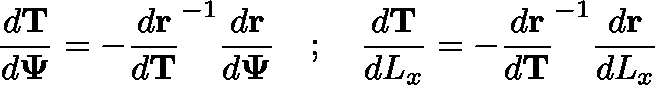Convert formula to latex. <formula><loc_0><loc_0><loc_500><loc_500>\frac { d T } { d \Psi } = - \frac { d r } { d T } ^ { - 1 } \frac { d r } { d \Psi } \quad ; \quad \frac { d T } { d L _ { x } } = - \frac { d r } { d T } ^ { - 1 } \frac { d r } { d L _ { x } }</formula> 